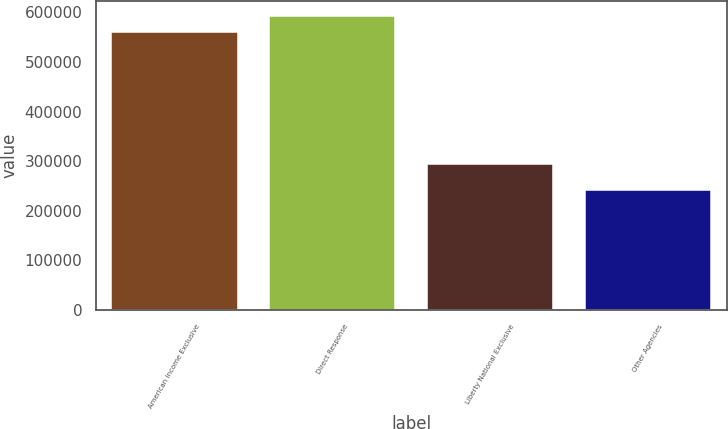Convert chart to OTSL. <chart><loc_0><loc_0><loc_500><loc_500><bar_chart><fcel>American Income Exclusive<fcel>Direct Response<fcel>Liberty National Exclusive<fcel>Other Agencies<nl><fcel>560649<fcel>593124<fcel>294587<fcel>241859<nl></chart> 